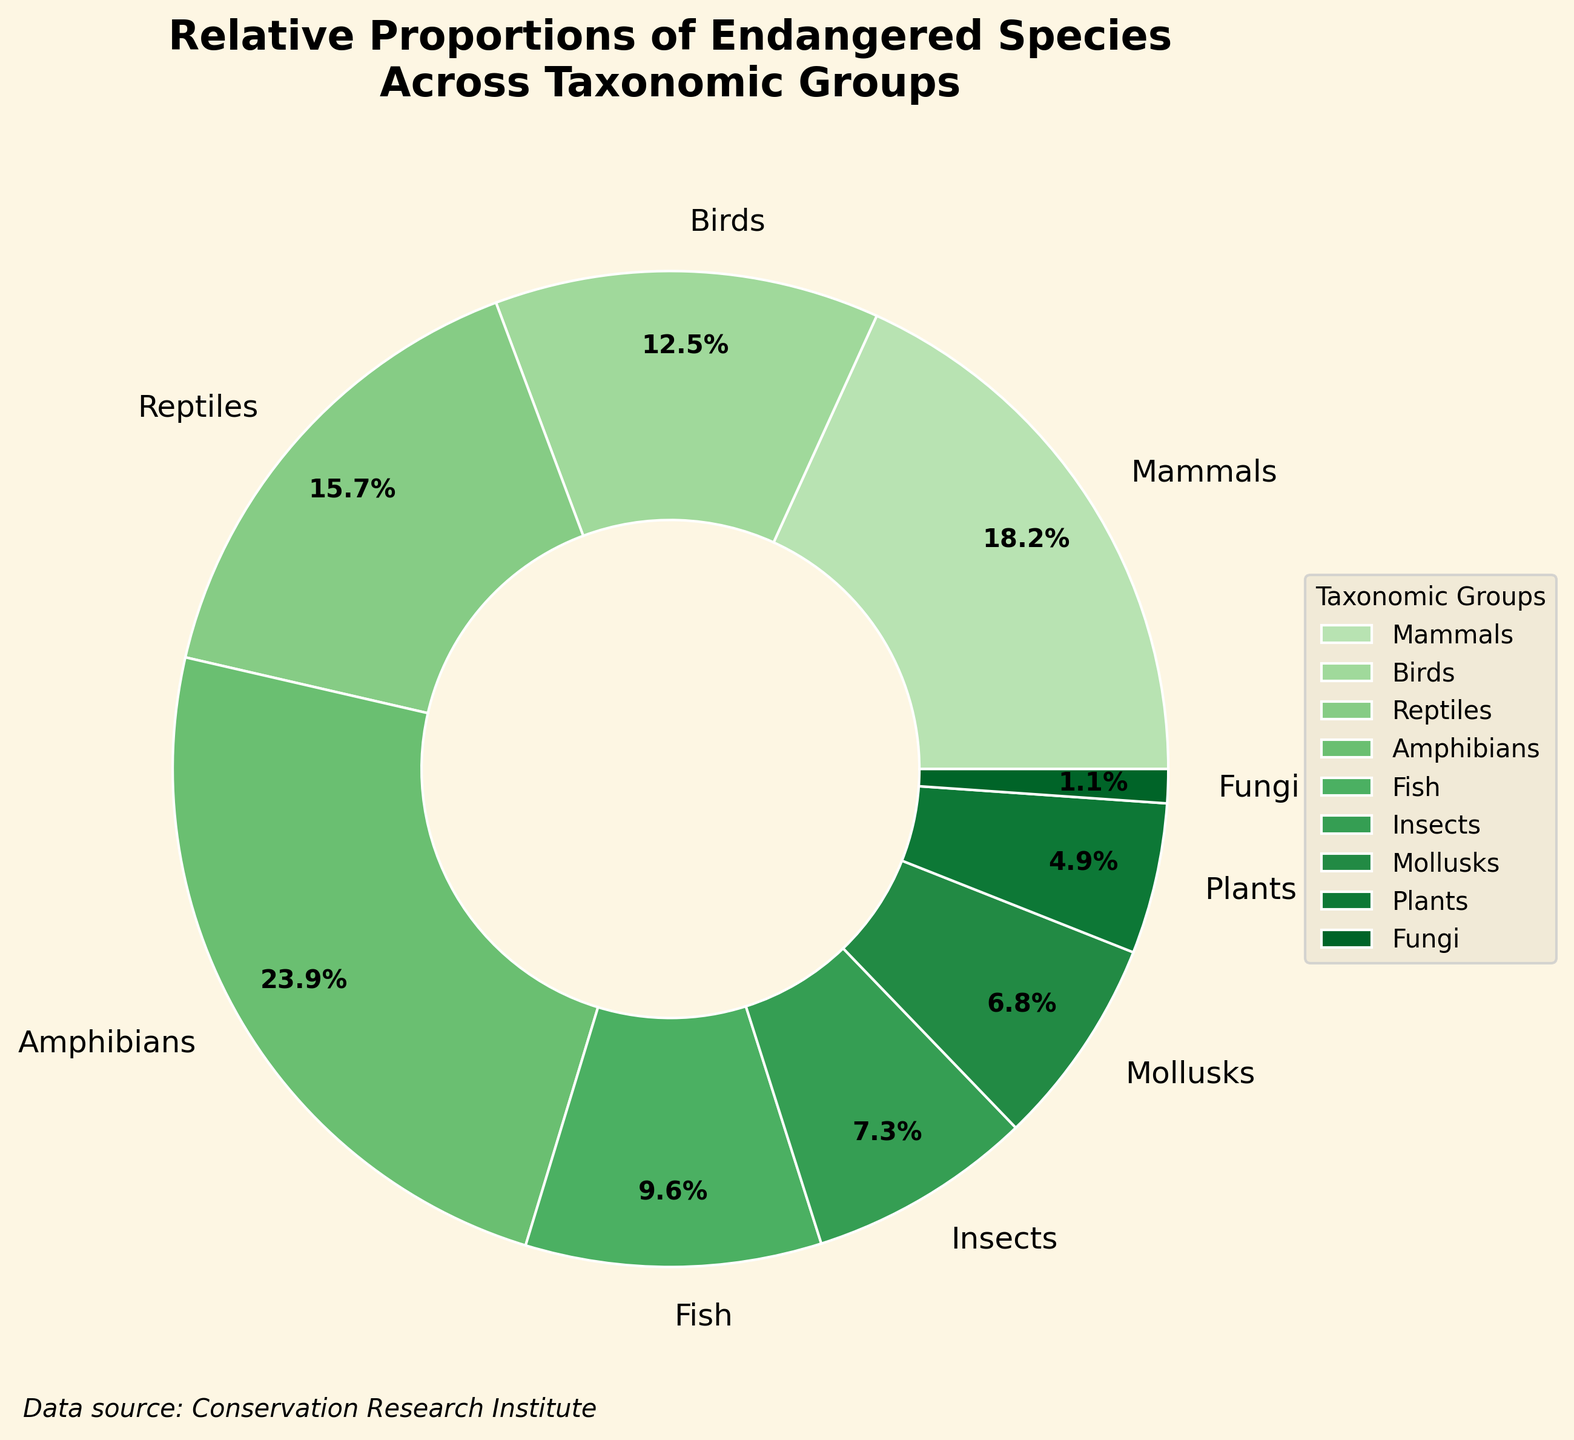What is the taxonomic group with the highest percentage of endangered species? By referring to the pie chart, you can observe that Amphibians have the largest wedge. Its percentage label reads 23.9%, which is higher than any other group's percentage.
Answer: Amphibians Which taxonomic group has the smallest percentage of endangered species? The smallest wedge in the pie chart corresponds to Fungi, with a label indicating 1.1%. This is the smallest percentage among all groups represented.
Answer: Fungi How many taxonomic groups have a percentage of endangered species greater than 15%? The taxonomic groups with more than 15% endangered species in the pie chart are Mammals (18.2%), Reptiles (15.7%), and Amphibians (23.9%). There are 3 such groups.
Answer: 3 Which groups have a higher percentage of endangered species than birds? Birds have a percentage of 12.5%. By comparing this with other groups, Mammals (18.2%), Reptiles (15.7%), and Amphibians (23.9%) have higher percentages.
Answer: Mammals, Reptiles, Amphibians What is the combined percentage of endangered species for Insects and Mollusks? The pie chart shows Insects with 7.3% and Mollusks with 6.8%. Adding these together gives 7.3% + 6.8% = 14.1%.
Answer: 14.1% How does the proportion of endangered plants compare to the proportion of endangered fungi? The chart shows Plants have 4.9%, and Fungi have 1.1%. Plants have a higher percentage than Fungi.
Answer: Plants have a higher percentage What is the average percentage of endangered species for the groups Fish, Insects, Mollusks, and Plants? Adding the percentages for these groups: Fish (9.6%), Insects (7.3%), Mollusks (6.8%), and Plants (4.9%) gives a total of 28.6%. Dividing this total by the number of groups (4) gives 28.6 / 4 = 7.15%.
Answer: 7.15% Which two taxonomic groups have the closest percentages of endangered species? By examining the pie chart, Insects (7.3%) and Mollusks (6.8%) have the closest percentages. The numerical difference between them is 7.3 - 6.8 = 0.5%.
Answer: Insects and Mollusks What is the total percentage of endangered species in taxonomic groups that have less than 10% each? Groups under 10% are Fish (9.6%), Insects (7.3%), Mollusks (6.8%), Plants (4.9%), and Fungi (1.1%). Summing these gives 9.6 + 7.3 + 6.8 + 4.9 + 1.1 = 29.7%.
Answer: 29.7% 